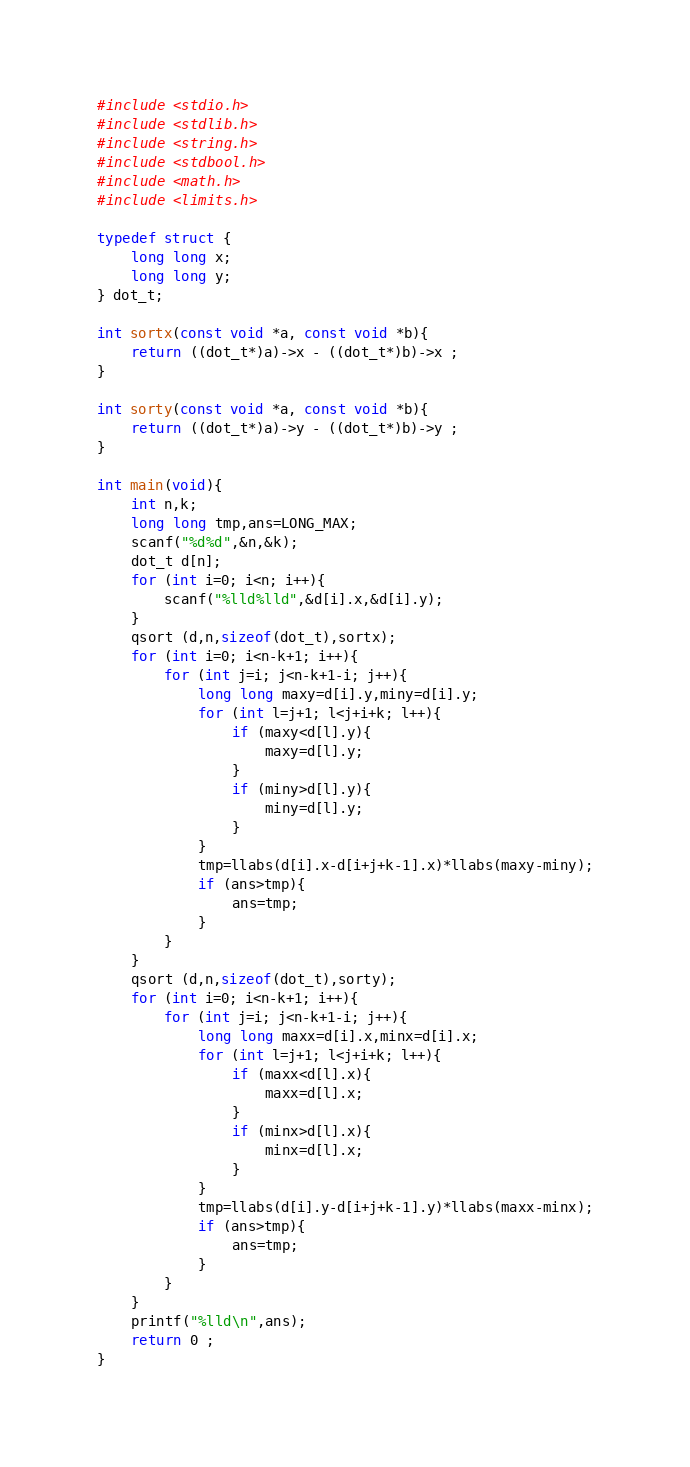<code> <loc_0><loc_0><loc_500><loc_500><_C_>#include <stdio.h>
#include <stdlib.h>
#include <string.h>
#include <stdbool.h>
#include <math.h>
#include <limits.h>

typedef struct {
    long long x;
    long long y;
} dot_t;

int sortx(const void *a, const void *b){
    return ((dot_t*)a)->x - ((dot_t*)b)->x ;
}

int sorty(const void *a, const void *b){
    return ((dot_t*)a)->y - ((dot_t*)b)->y ;
}

int main(void){
    int n,k;
    long long tmp,ans=LONG_MAX;
    scanf("%d%d",&n,&k);
    dot_t d[n];
    for (int i=0; i<n; i++){
        scanf("%lld%lld",&d[i].x,&d[i].y);
    }
    qsort (d,n,sizeof(dot_t),sortx);
    for (int i=0; i<n-k+1; i++){
        for (int j=i; j<n-k+1-i; j++){
            long long maxy=d[i].y,miny=d[i].y;
            for (int l=j+1; l<j+i+k; l++){
                if (maxy<d[l].y){
                    maxy=d[l].y;
                }
                if (miny>d[l].y){
                    miny=d[l].y;
                }
            }
            tmp=llabs(d[i].x-d[i+j+k-1].x)*llabs(maxy-miny);
            if (ans>tmp){
                ans=tmp;
            }
        }
    }
    qsort (d,n,sizeof(dot_t),sorty);
    for (int i=0; i<n-k+1; i++){
        for (int j=i; j<n-k+1-i; j++){
            long long maxx=d[i].x,minx=d[i].x;
            for (int l=j+1; l<j+i+k; l++){
                if (maxx<d[l].x){
                    maxx=d[l].x;
                }
                if (minx>d[l].x){
                    minx=d[l].x;
                }
            }
            tmp=llabs(d[i].y-d[i+j+k-1].y)*llabs(maxx-minx);
            if (ans>tmp){
                ans=tmp;
            }
        }
    }
    printf("%lld\n",ans);
    return 0 ;
}</code> 